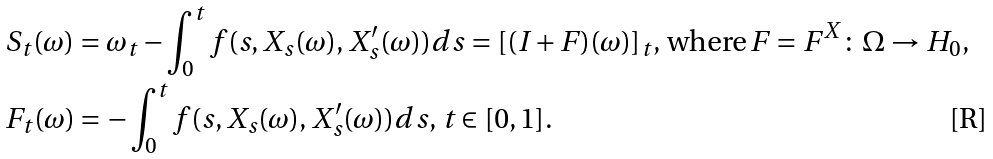Convert formula to latex. <formula><loc_0><loc_0><loc_500><loc_500>& S _ { t } ( \omega ) = \omega _ { t } - \int _ { 0 } ^ { t } f ( s , X _ { s } ( \omega ) , X _ { s } ^ { \prime } ( \omega ) ) d s = [ ( I + F ) ( \omega ) ] _ { t } , \, \text {where} \, F = F ^ { X } \colon \Omega \to H _ { 0 } , \\ & F _ { t } ( \omega ) = - \int _ { 0 } ^ { t } f ( s , X _ { s } ( \omega ) , X _ { s } ^ { \prime } ( \omega ) ) d s , \, t \in [ 0 , 1 ] .</formula> 